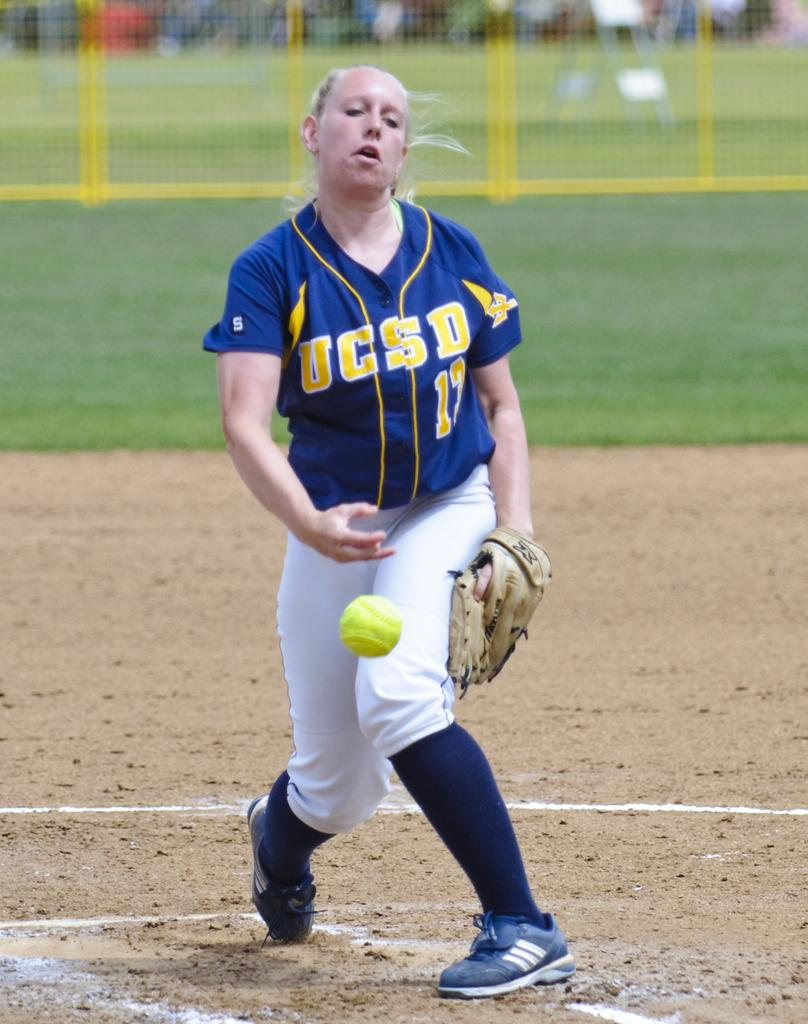<image>
Give a short and clear explanation of the subsequent image. A pitcher from UCSD tosses the ball from the mound. 